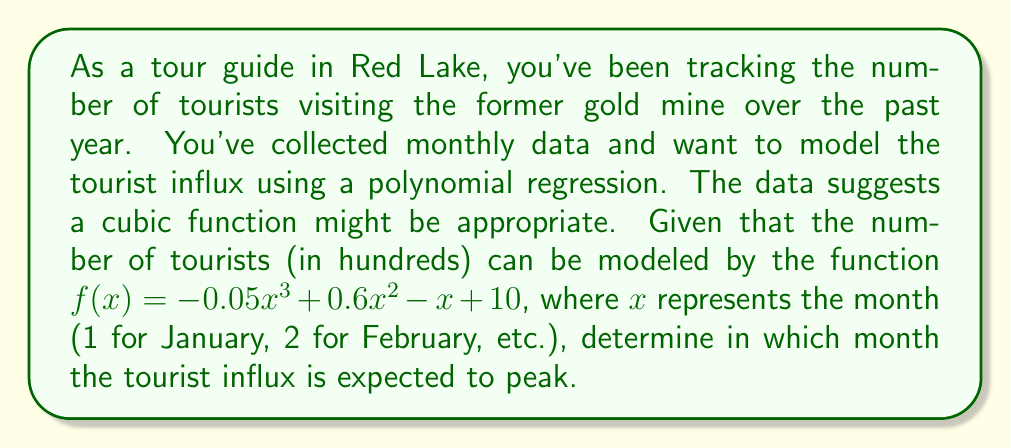Give your solution to this math problem. To find the month with the peak tourist influx, we need to determine the maximum point of the cubic function. This can be done by following these steps:

1) First, we need to find the derivative of the function:
   $f'(x) = -0.15x^2 + 1.2x - 1$

2) To find the critical points, set $f'(x) = 0$:
   $-0.15x^2 + 1.2x - 1 = 0$

3) This is a quadratic equation. We can solve it using the quadratic formula:
   $x = \frac{-b \pm \sqrt{b^2 - 4ac}}{2a}$

   Where $a = -0.15$, $b = 1.2$, and $c = -1$

4) Plugging these values into the quadratic formula:
   $x = \frac{-1.2 \pm \sqrt{1.44 - 4(-0.15)(-1)}}{2(-0.15)}$
   $= \frac{-1.2 \pm \sqrt{1.44 - 0.6}}{-0.3}$
   $= \frac{-1.2 \pm \sqrt{0.84}}{-0.3}$
   $= \frac{-1.2 \pm 0.9165}{-0.3}$

5) This gives us two solutions:
   $x_1 = \frac{-1.2 + 0.9165}{-0.3} \approx 0.945$
   $x_2 = \frac{-1.2 - 0.9165}{-0.3} \approx 7.055$

6) Since we're dealing with months, we round these to the nearest whole number: 1 and 7.

7) To determine which of these is the maximum (rather than minimum), we can check the second derivative:
   $f''(x) = -0.3x + 1.2$

8) Evaluating $f''(x)$ at $x = 7$:
   $f''(7) = -0.3(7) + 1.2 = -0.9 < 0$

   This confirms that $x = 7$ is indeed a local maximum.

Therefore, the tourist influx is expected to peak in the 7th month, which is July.
Answer: July (the 7th month) 